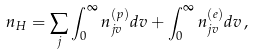<formula> <loc_0><loc_0><loc_500><loc_500>n _ { H } = \sum _ { j } \int _ { 0 } ^ { \infty } n _ { j v } ^ { ( p ) } d v + \int _ { 0 } ^ { \infty } n _ { j v } ^ { ( e ) } d v \, ,</formula> 